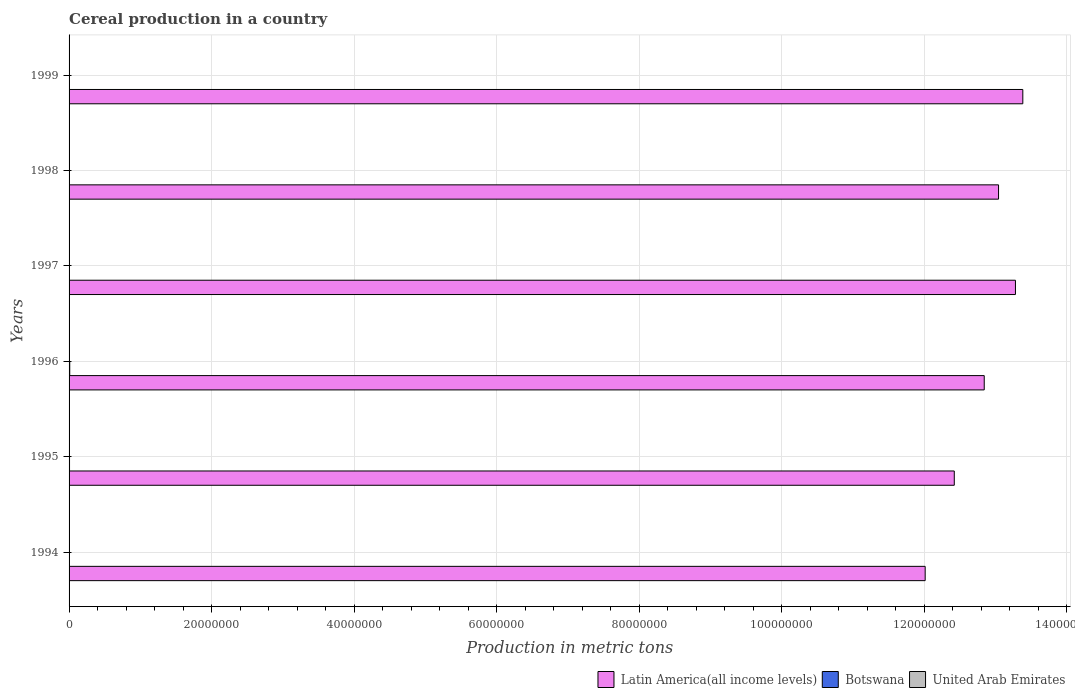How many different coloured bars are there?
Offer a terse response. 3. In how many cases, is the number of bars for a given year not equal to the number of legend labels?
Your answer should be very brief. 0. What is the total cereal production in Latin America(all income levels) in 1998?
Provide a short and direct response. 1.30e+08. Across all years, what is the maximum total cereal production in United Arab Emirates?
Your answer should be very brief. 1052. Across all years, what is the minimum total cereal production in Latin America(all income levels)?
Your answer should be compact. 1.20e+08. In which year was the total cereal production in United Arab Emirates minimum?
Offer a very short reply. 1999. What is the total total cereal production in Botswana in the graph?
Your response must be concise. 2.97e+05. What is the difference between the total cereal production in Botswana in 1997 and that in 1998?
Make the answer very short. 3.32e+04. What is the difference between the total cereal production in Latin America(all income levels) in 1994 and the total cereal production in Botswana in 1999?
Provide a short and direct response. 1.20e+08. What is the average total cereal production in United Arab Emirates per year?
Your answer should be very brief. 582.5. In the year 1998, what is the difference between the total cereal production in Botswana and total cereal production in Latin America(all income levels)?
Ensure brevity in your answer.  -1.30e+08. In how many years, is the total cereal production in Botswana greater than 100000000 metric tons?
Provide a short and direct response. 0. What is the ratio of the total cereal production in Botswana in 1997 to that in 1999?
Your answer should be very brief. 2.34. Is the total cereal production in United Arab Emirates in 1995 less than that in 1998?
Provide a succinct answer. No. What is the difference between the highest and the second highest total cereal production in Latin America(all income levels)?
Provide a short and direct response. 1.03e+06. What is the difference between the highest and the lowest total cereal production in United Arab Emirates?
Provide a short and direct response. 840. In how many years, is the total cereal production in United Arab Emirates greater than the average total cereal production in United Arab Emirates taken over all years?
Give a very brief answer. 3. What does the 1st bar from the top in 1995 represents?
Ensure brevity in your answer.  United Arab Emirates. What does the 1st bar from the bottom in 1996 represents?
Make the answer very short. Latin America(all income levels). Is it the case that in every year, the sum of the total cereal production in Latin America(all income levels) and total cereal production in United Arab Emirates is greater than the total cereal production in Botswana?
Offer a terse response. Yes. How many bars are there?
Give a very brief answer. 18. How many years are there in the graph?
Your answer should be very brief. 6. What is the difference between two consecutive major ticks on the X-axis?
Give a very brief answer. 2.00e+07. Does the graph contain any zero values?
Provide a succinct answer. No. Does the graph contain grids?
Your answer should be very brief. Yes. How many legend labels are there?
Your answer should be very brief. 3. What is the title of the graph?
Your answer should be very brief. Cereal production in a country. Does "Qatar" appear as one of the legend labels in the graph?
Provide a short and direct response. No. What is the label or title of the X-axis?
Give a very brief answer. Production in metric tons. What is the Production in metric tons in Latin America(all income levels) in 1994?
Ensure brevity in your answer.  1.20e+08. What is the Production in metric tons in Botswana in 1994?
Your answer should be very brief. 5.61e+04. What is the Production in metric tons of United Arab Emirates in 1994?
Ensure brevity in your answer.  1052. What is the Production in metric tons in Latin America(all income levels) in 1995?
Your answer should be very brief. 1.24e+08. What is the Production in metric tons of Botswana in 1995?
Keep it short and to the point. 6.42e+04. What is the Production in metric tons in United Arab Emirates in 1995?
Give a very brief answer. 972. What is the Production in metric tons in Latin America(all income levels) in 1996?
Keep it short and to the point. 1.28e+08. What is the Production in metric tons in Botswana in 1996?
Ensure brevity in your answer.  9.29e+04. What is the Production in metric tons in United Arab Emirates in 1996?
Offer a terse response. 601. What is the Production in metric tons of Latin America(all income levels) in 1997?
Offer a very short reply. 1.33e+08. What is the Production in metric tons in Botswana in 1997?
Give a very brief answer. 4.81e+04. What is the Production in metric tons in United Arab Emirates in 1997?
Offer a very short reply. 298. What is the Production in metric tons in Latin America(all income levels) in 1998?
Make the answer very short. 1.30e+08. What is the Production in metric tons of Botswana in 1998?
Offer a terse response. 1.49e+04. What is the Production in metric tons of United Arab Emirates in 1998?
Ensure brevity in your answer.  360. What is the Production in metric tons in Latin America(all income levels) in 1999?
Your answer should be compact. 1.34e+08. What is the Production in metric tons of Botswana in 1999?
Ensure brevity in your answer.  2.06e+04. What is the Production in metric tons in United Arab Emirates in 1999?
Your answer should be very brief. 212. Across all years, what is the maximum Production in metric tons of Latin America(all income levels)?
Your answer should be compact. 1.34e+08. Across all years, what is the maximum Production in metric tons in Botswana?
Offer a very short reply. 9.29e+04. Across all years, what is the maximum Production in metric tons in United Arab Emirates?
Make the answer very short. 1052. Across all years, what is the minimum Production in metric tons of Latin America(all income levels)?
Ensure brevity in your answer.  1.20e+08. Across all years, what is the minimum Production in metric tons of Botswana?
Make the answer very short. 1.49e+04. Across all years, what is the minimum Production in metric tons of United Arab Emirates?
Make the answer very short. 212. What is the total Production in metric tons of Latin America(all income levels) in the graph?
Offer a terse response. 7.70e+08. What is the total Production in metric tons of Botswana in the graph?
Offer a very short reply. 2.97e+05. What is the total Production in metric tons of United Arab Emirates in the graph?
Keep it short and to the point. 3495. What is the difference between the Production in metric tons in Latin America(all income levels) in 1994 and that in 1995?
Make the answer very short. -4.09e+06. What is the difference between the Production in metric tons in Botswana in 1994 and that in 1995?
Provide a short and direct response. -8049. What is the difference between the Production in metric tons of Latin America(all income levels) in 1994 and that in 1996?
Give a very brief answer. -8.29e+06. What is the difference between the Production in metric tons of Botswana in 1994 and that in 1996?
Ensure brevity in your answer.  -3.68e+04. What is the difference between the Production in metric tons of United Arab Emirates in 1994 and that in 1996?
Your answer should be very brief. 451. What is the difference between the Production in metric tons of Latin America(all income levels) in 1994 and that in 1997?
Give a very brief answer. -1.27e+07. What is the difference between the Production in metric tons of Botswana in 1994 and that in 1997?
Ensure brevity in your answer.  8030. What is the difference between the Production in metric tons of United Arab Emirates in 1994 and that in 1997?
Your answer should be very brief. 754. What is the difference between the Production in metric tons in Latin America(all income levels) in 1994 and that in 1998?
Provide a short and direct response. -1.03e+07. What is the difference between the Production in metric tons in Botswana in 1994 and that in 1998?
Provide a succinct answer. 4.12e+04. What is the difference between the Production in metric tons in United Arab Emirates in 1994 and that in 1998?
Ensure brevity in your answer.  692. What is the difference between the Production in metric tons in Latin America(all income levels) in 1994 and that in 1999?
Make the answer very short. -1.37e+07. What is the difference between the Production in metric tons of Botswana in 1994 and that in 1999?
Make the answer very short. 3.55e+04. What is the difference between the Production in metric tons of United Arab Emirates in 1994 and that in 1999?
Your answer should be compact. 840. What is the difference between the Production in metric tons in Latin America(all income levels) in 1995 and that in 1996?
Offer a terse response. -4.20e+06. What is the difference between the Production in metric tons in Botswana in 1995 and that in 1996?
Provide a succinct answer. -2.87e+04. What is the difference between the Production in metric tons of United Arab Emirates in 1995 and that in 1996?
Offer a very short reply. 371. What is the difference between the Production in metric tons of Latin America(all income levels) in 1995 and that in 1997?
Give a very brief answer. -8.58e+06. What is the difference between the Production in metric tons of Botswana in 1995 and that in 1997?
Keep it short and to the point. 1.61e+04. What is the difference between the Production in metric tons of United Arab Emirates in 1995 and that in 1997?
Your answer should be compact. 674. What is the difference between the Production in metric tons of Latin America(all income levels) in 1995 and that in 1998?
Your answer should be very brief. -6.21e+06. What is the difference between the Production in metric tons of Botswana in 1995 and that in 1998?
Offer a terse response. 4.92e+04. What is the difference between the Production in metric tons in United Arab Emirates in 1995 and that in 1998?
Make the answer very short. 612. What is the difference between the Production in metric tons in Latin America(all income levels) in 1995 and that in 1999?
Keep it short and to the point. -9.61e+06. What is the difference between the Production in metric tons of Botswana in 1995 and that in 1999?
Your response must be concise. 4.36e+04. What is the difference between the Production in metric tons of United Arab Emirates in 1995 and that in 1999?
Make the answer very short. 760. What is the difference between the Production in metric tons of Latin America(all income levels) in 1996 and that in 1997?
Your response must be concise. -4.38e+06. What is the difference between the Production in metric tons in Botswana in 1996 and that in 1997?
Your response must be concise. 4.48e+04. What is the difference between the Production in metric tons in United Arab Emirates in 1996 and that in 1997?
Offer a very short reply. 303. What is the difference between the Production in metric tons in Latin America(all income levels) in 1996 and that in 1998?
Your answer should be compact. -2.01e+06. What is the difference between the Production in metric tons in Botswana in 1996 and that in 1998?
Make the answer very short. 7.80e+04. What is the difference between the Production in metric tons in United Arab Emirates in 1996 and that in 1998?
Make the answer very short. 241. What is the difference between the Production in metric tons of Latin America(all income levels) in 1996 and that in 1999?
Provide a succinct answer. -5.41e+06. What is the difference between the Production in metric tons of Botswana in 1996 and that in 1999?
Provide a short and direct response. 7.23e+04. What is the difference between the Production in metric tons in United Arab Emirates in 1996 and that in 1999?
Provide a succinct answer. 389. What is the difference between the Production in metric tons in Latin America(all income levels) in 1997 and that in 1998?
Your answer should be compact. 2.37e+06. What is the difference between the Production in metric tons in Botswana in 1997 and that in 1998?
Your response must be concise. 3.32e+04. What is the difference between the Production in metric tons in United Arab Emirates in 1997 and that in 1998?
Your response must be concise. -62. What is the difference between the Production in metric tons of Latin America(all income levels) in 1997 and that in 1999?
Provide a succinct answer. -1.03e+06. What is the difference between the Production in metric tons of Botswana in 1997 and that in 1999?
Provide a succinct answer. 2.75e+04. What is the difference between the Production in metric tons in United Arab Emirates in 1997 and that in 1999?
Your answer should be very brief. 86. What is the difference between the Production in metric tons of Latin America(all income levels) in 1998 and that in 1999?
Give a very brief answer. -3.40e+06. What is the difference between the Production in metric tons of Botswana in 1998 and that in 1999?
Provide a short and direct response. -5644. What is the difference between the Production in metric tons in United Arab Emirates in 1998 and that in 1999?
Ensure brevity in your answer.  148. What is the difference between the Production in metric tons in Latin America(all income levels) in 1994 and the Production in metric tons in Botswana in 1995?
Your response must be concise. 1.20e+08. What is the difference between the Production in metric tons of Latin America(all income levels) in 1994 and the Production in metric tons of United Arab Emirates in 1995?
Offer a terse response. 1.20e+08. What is the difference between the Production in metric tons in Botswana in 1994 and the Production in metric tons in United Arab Emirates in 1995?
Give a very brief answer. 5.52e+04. What is the difference between the Production in metric tons in Latin America(all income levels) in 1994 and the Production in metric tons in Botswana in 1996?
Keep it short and to the point. 1.20e+08. What is the difference between the Production in metric tons of Latin America(all income levels) in 1994 and the Production in metric tons of United Arab Emirates in 1996?
Keep it short and to the point. 1.20e+08. What is the difference between the Production in metric tons of Botswana in 1994 and the Production in metric tons of United Arab Emirates in 1996?
Make the answer very short. 5.55e+04. What is the difference between the Production in metric tons in Latin America(all income levels) in 1994 and the Production in metric tons in Botswana in 1997?
Ensure brevity in your answer.  1.20e+08. What is the difference between the Production in metric tons in Latin America(all income levels) in 1994 and the Production in metric tons in United Arab Emirates in 1997?
Your response must be concise. 1.20e+08. What is the difference between the Production in metric tons in Botswana in 1994 and the Production in metric tons in United Arab Emirates in 1997?
Keep it short and to the point. 5.58e+04. What is the difference between the Production in metric tons of Latin America(all income levels) in 1994 and the Production in metric tons of Botswana in 1998?
Provide a short and direct response. 1.20e+08. What is the difference between the Production in metric tons of Latin America(all income levels) in 1994 and the Production in metric tons of United Arab Emirates in 1998?
Your answer should be compact. 1.20e+08. What is the difference between the Production in metric tons of Botswana in 1994 and the Production in metric tons of United Arab Emirates in 1998?
Offer a very short reply. 5.58e+04. What is the difference between the Production in metric tons in Latin America(all income levels) in 1994 and the Production in metric tons in Botswana in 1999?
Offer a terse response. 1.20e+08. What is the difference between the Production in metric tons in Latin America(all income levels) in 1994 and the Production in metric tons in United Arab Emirates in 1999?
Provide a succinct answer. 1.20e+08. What is the difference between the Production in metric tons in Botswana in 1994 and the Production in metric tons in United Arab Emirates in 1999?
Your response must be concise. 5.59e+04. What is the difference between the Production in metric tons in Latin America(all income levels) in 1995 and the Production in metric tons in Botswana in 1996?
Your answer should be very brief. 1.24e+08. What is the difference between the Production in metric tons in Latin America(all income levels) in 1995 and the Production in metric tons in United Arab Emirates in 1996?
Your answer should be very brief. 1.24e+08. What is the difference between the Production in metric tons in Botswana in 1995 and the Production in metric tons in United Arab Emirates in 1996?
Your answer should be very brief. 6.36e+04. What is the difference between the Production in metric tons of Latin America(all income levels) in 1995 and the Production in metric tons of Botswana in 1997?
Offer a very short reply. 1.24e+08. What is the difference between the Production in metric tons in Latin America(all income levels) in 1995 and the Production in metric tons in United Arab Emirates in 1997?
Give a very brief answer. 1.24e+08. What is the difference between the Production in metric tons of Botswana in 1995 and the Production in metric tons of United Arab Emirates in 1997?
Provide a short and direct response. 6.39e+04. What is the difference between the Production in metric tons in Latin America(all income levels) in 1995 and the Production in metric tons in Botswana in 1998?
Your answer should be compact. 1.24e+08. What is the difference between the Production in metric tons in Latin America(all income levels) in 1995 and the Production in metric tons in United Arab Emirates in 1998?
Your answer should be compact. 1.24e+08. What is the difference between the Production in metric tons of Botswana in 1995 and the Production in metric tons of United Arab Emirates in 1998?
Your answer should be compact. 6.38e+04. What is the difference between the Production in metric tons in Latin America(all income levels) in 1995 and the Production in metric tons in Botswana in 1999?
Provide a succinct answer. 1.24e+08. What is the difference between the Production in metric tons in Latin America(all income levels) in 1995 and the Production in metric tons in United Arab Emirates in 1999?
Provide a succinct answer. 1.24e+08. What is the difference between the Production in metric tons in Botswana in 1995 and the Production in metric tons in United Arab Emirates in 1999?
Offer a very short reply. 6.40e+04. What is the difference between the Production in metric tons of Latin America(all income levels) in 1996 and the Production in metric tons of Botswana in 1997?
Ensure brevity in your answer.  1.28e+08. What is the difference between the Production in metric tons of Latin America(all income levels) in 1996 and the Production in metric tons of United Arab Emirates in 1997?
Provide a succinct answer. 1.28e+08. What is the difference between the Production in metric tons of Botswana in 1996 and the Production in metric tons of United Arab Emirates in 1997?
Offer a very short reply. 9.26e+04. What is the difference between the Production in metric tons of Latin America(all income levels) in 1996 and the Production in metric tons of Botswana in 1998?
Offer a terse response. 1.28e+08. What is the difference between the Production in metric tons of Latin America(all income levels) in 1996 and the Production in metric tons of United Arab Emirates in 1998?
Ensure brevity in your answer.  1.28e+08. What is the difference between the Production in metric tons of Botswana in 1996 and the Production in metric tons of United Arab Emirates in 1998?
Make the answer very short. 9.25e+04. What is the difference between the Production in metric tons of Latin America(all income levels) in 1996 and the Production in metric tons of Botswana in 1999?
Offer a terse response. 1.28e+08. What is the difference between the Production in metric tons of Latin America(all income levels) in 1996 and the Production in metric tons of United Arab Emirates in 1999?
Ensure brevity in your answer.  1.28e+08. What is the difference between the Production in metric tons in Botswana in 1996 and the Production in metric tons in United Arab Emirates in 1999?
Offer a terse response. 9.27e+04. What is the difference between the Production in metric tons of Latin America(all income levels) in 1997 and the Production in metric tons of Botswana in 1998?
Ensure brevity in your answer.  1.33e+08. What is the difference between the Production in metric tons of Latin America(all income levels) in 1997 and the Production in metric tons of United Arab Emirates in 1998?
Provide a short and direct response. 1.33e+08. What is the difference between the Production in metric tons in Botswana in 1997 and the Production in metric tons in United Arab Emirates in 1998?
Make the answer very short. 4.77e+04. What is the difference between the Production in metric tons of Latin America(all income levels) in 1997 and the Production in metric tons of Botswana in 1999?
Your answer should be compact. 1.33e+08. What is the difference between the Production in metric tons in Latin America(all income levels) in 1997 and the Production in metric tons in United Arab Emirates in 1999?
Your answer should be compact. 1.33e+08. What is the difference between the Production in metric tons in Botswana in 1997 and the Production in metric tons in United Arab Emirates in 1999?
Provide a succinct answer. 4.79e+04. What is the difference between the Production in metric tons of Latin America(all income levels) in 1998 and the Production in metric tons of Botswana in 1999?
Ensure brevity in your answer.  1.30e+08. What is the difference between the Production in metric tons of Latin America(all income levels) in 1998 and the Production in metric tons of United Arab Emirates in 1999?
Ensure brevity in your answer.  1.30e+08. What is the difference between the Production in metric tons in Botswana in 1998 and the Production in metric tons in United Arab Emirates in 1999?
Make the answer very short. 1.47e+04. What is the average Production in metric tons of Latin America(all income levels) per year?
Keep it short and to the point. 1.28e+08. What is the average Production in metric tons in Botswana per year?
Make the answer very short. 4.95e+04. What is the average Production in metric tons of United Arab Emirates per year?
Your answer should be compact. 582.5. In the year 1994, what is the difference between the Production in metric tons of Latin America(all income levels) and Production in metric tons of Botswana?
Offer a very short reply. 1.20e+08. In the year 1994, what is the difference between the Production in metric tons in Latin America(all income levels) and Production in metric tons in United Arab Emirates?
Provide a succinct answer. 1.20e+08. In the year 1994, what is the difference between the Production in metric tons in Botswana and Production in metric tons in United Arab Emirates?
Offer a terse response. 5.51e+04. In the year 1995, what is the difference between the Production in metric tons of Latin America(all income levels) and Production in metric tons of Botswana?
Keep it short and to the point. 1.24e+08. In the year 1995, what is the difference between the Production in metric tons of Latin America(all income levels) and Production in metric tons of United Arab Emirates?
Keep it short and to the point. 1.24e+08. In the year 1995, what is the difference between the Production in metric tons in Botswana and Production in metric tons in United Arab Emirates?
Provide a succinct answer. 6.32e+04. In the year 1996, what is the difference between the Production in metric tons of Latin America(all income levels) and Production in metric tons of Botswana?
Provide a succinct answer. 1.28e+08. In the year 1996, what is the difference between the Production in metric tons of Latin America(all income levels) and Production in metric tons of United Arab Emirates?
Your answer should be compact. 1.28e+08. In the year 1996, what is the difference between the Production in metric tons of Botswana and Production in metric tons of United Arab Emirates?
Ensure brevity in your answer.  9.23e+04. In the year 1997, what is the difference between the Production in metric tons of Latin America(all income levels) and Production in metric tons of Botswana?
Give a very brief answer. 1.33e+08. In the year 1997, what is the difference between the Production in metric tons in Latin America(all income levels) and Production in metric tons in United Arab Emirates?
Ensure brevity in your answer.  1.33e+08. In the year 1997, what is the difference between the Production in metric tons in Botswana and Production in metric tons in United Arab Emirates?
Your answer should be very brief. 4.78e+04. In the year 1998, what is the difference between the Production in metric tons of Latin America(all income levels) and Production in metric tons of Botswana?
Ensure brevity in your answer.  1.30e+08. In the year 1998, what is the difference between the Production in metric tons of Latin America(all income levels) and Production in metric tons of United Arab Emirates?
Your answer should be compact. 1.30e+08. In the year 1998, what is the difference between the Production in metric tons of Botswana and Production in metric tons of United Arab Emirates?
Offer a terse response. 1.46e+04. In the year 1999, what is the difference between the Production in metric tons in Latin America(all income levels) and Production in metric tons in Botswana?
Give a very brief answer. 1.34e+08. In the year 1999, what is the difference between the Production in metric tons of Latin America(all income levels) and Production in metric tons of United Arab Emirates?
Provide a succinct answer. 1.34e+08. In the year 1999, what is the difference between the Production in metric tons in Botswana and Production in metric tons in United Arab Emirates?
Ensure brevity in your answer.  2.04e+04. What is the ratio of the Production in metric tons in Latin America(all income levels) in 1994 to that in 1995?
Your answer should be very brief. 0.97. What is the ratio of the Production in metric tons of Botswana in 1994 to that in 1995?
Keep it short and to the point. 0.87. What is the ratio of the Production in metric tons of United Arab Emirates in 1994 to that in 1995?
Ensure brevity in your answer.  1.08. What is the ratio of the Production in metric tons in Latin America(all income levels) in 1994 to that in 1996?
Ensure brevity in your answer.  0.94. What is the ratio of the Production in metric tons of Botswana in 1994 to that in 1996?
Keep it short and to the point. 0.6. What is the ratio of the Production in metric tons of United Arab Emirates in 1994 to that in 1996?
Provide a short and direct response. 1.75. What is the ratio of the Production in metric tons of Latin America(all income levels) in 1994 to that in 1997?
Your answer should be compact. 0.9. What is the ratio of the Production in metric tons in Botswana in 1994 to that in 1997?
Offer a terse response. 1.17. What is the ratio of the Production in metric tons in United Arab Emirates in 1994 to that in 1997?
Ensure brevity in your answer.  3.53. What is the ratio of the Production in metric tons of Latin America(all income levels) in 1994 to that in 1998?
Give a very brief answer. 0.92. What is the ratio of the Production in metric tons of Botswana in 1994 to that in 1998?
Your answer should be very brief. 3.76. What is the ratio of the Production in metric tons of United Arab Emirates in 1994 to that in 1998?
Give a very brief answer. 2.92. What is the ratio of the Production in metric tons of Latin America(all income levels) in 1994 to that in 1999?
Offer a terse response. 0.9. What is the ratio of the Production in metric tons in Botswana in 1994 to that in 1999?
Make the answer very short. 2.73. What is the ratio of the Production in metric tons of United Arab Emirates in 1994 to that in 1999?
Ensure brevity in your answer.  4.96. What is the ratio of the Production in metric tons in Latin America(all income levels) in 1995 to that in 1996?
Your answer should be very brief. 0.97. What is the ratio of the Production in metric tons in Botswana in 1995 to that in 1996?
Offer a very short reply. 0.69. What is the ratio of the Production in metric tons of United Arab Emirates in 1995 to that in 1996?
Provide a succinct answer. 1.62. What is the ratio of the Production in metric tons of Latin America(all income levels) in 1995 to that in 1997?
Offer a terse response. 0.94. What is the ratio of the Production in metric tons in Botswana in 1995 to that in 1997?
Give a very brief answer. 1.33. What is the ratio of the Production in metric tons of United Arab Emirates in 1995 to that in 1997?
Give a very brief answer. 3.26. What is the ratio of the Production in metric tons of Botswana in 1995 to that in 1998?
Your response must be concise. 4.3. What is the ratio of the Production in metric tons of Latin America(all income levels) in 1995 to that in 1999?
Your answer should be compact. 0.93. What is the ratio of the Production in metric tons in Botswana in 1995 to that in 1999?
Make the answer very short. 3.12. What is the ratio of the Production in metric tons in United Arab Emirates in 1995 to that in 1999?
Give a very brief answer. 4.58. What is the ratio of the Production in metric tons of Botswana in 1996 to that in 1997?
Keep it short and to the point. 1.93. What is the ratio of the Production in metric tons in United Arab Emirates in 1996 to that in 1997?
Provide a short and direct response. 2.02. What is the ratio of the Production in metric tons of Latin America(all income levels) in 1996 to that in 1998?
Ensure brevity in your answer.  0.98. What is the ratio of the Production in metric tons in Botswana in 1996 to that in 1998?
Offer a very short reply. 6.22. What is the ratio of the Production in metric tons of United Arab Emirates in 1996 to that in 1998?
Keep it short and to the point. 1.67. What is the ratio of the Production in metric tons in Latin America(all income levels) in 1996 to that in 1999?
Make the answer very short. 0.96. What is the ratio of the Production in metric tons in Botswana in 1996 to that in 1999?
Your answer should be compact. 4.51. What is the ratio of the Production in metric tons of United Arab Emirates in 1996 to that in 1999?
Your response must be concise. 2.83. What is the ratio of the Production in metric tons in Latin America(all income levels) in 1997 to that in 1998?
Your response must be concise. 1.02. What is the ratio of the Production in metric tons in Botswana in 1997 to that in 1998?
Provide a succinct answer. 3.22. What is the ratio of the Production in metric tons in United Arab Emirates in 1997 to that in 1998?
Your answer should be very brief. 0.83. What is the ratio of the Production in metric tons of Latin America(all income levels) in 1997 to that in 1999?
Provide a short and direct response. 0.99. What is the ratio of the Production in metric tons of Botswana in 1997 to that in 1999?
Keep it short and to the point. 2.34. What is the ratio of the Production in metric tons of United Arab Emirates in 1997 to that in 1999?
Keep it short and to the point. 1.41. What is the ratio of the Production in metric tons in Latin America(all income levels) in 1998 to that in 1999?
Keep it short and to the point. 0.97. What is the ratio of the Production in metric tons of Botswana in 1998 to that in 1999?
Keep it short and to the point. 0.73. What is the ratio of the Production in metric tons of United Arab Emirates in 1998 to that in 1999?
Your answer should be very brief. 1.7. What is the difference between the highest and the second highest Production in metric tons in Latin America(all income levels)?
Keep it short and to the point. 1.03e+06. What is the difference between the highest and the second highest Production in metric tons of Botswana?
Your answer should be very brief. 2.87e+04. What is the difference between the highest and the lowest Production in metric tons in Latin America(all income levels)?
Your answer should be compact. 1.37e+07. What is the difference between the highest and the lowest Production in metric tons in Botswana?
Ensure brevity in your answer.  7.80e+04. What is the difference between the highest and the lowest Production in metric tons in United Arab Emirates?
Ensure brevity in your answer.  840. 